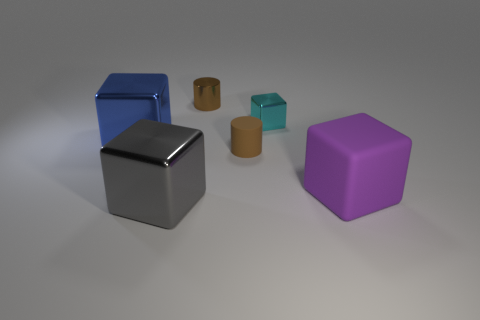Are all the objects in the image the same shape? No, the objects are not all the same shape. There are cubes and cuboids present. Cubes have equal dimensions on all sides, while cuboids, often referred to as rectangular prisms, have different lengths, widths, and heights. 